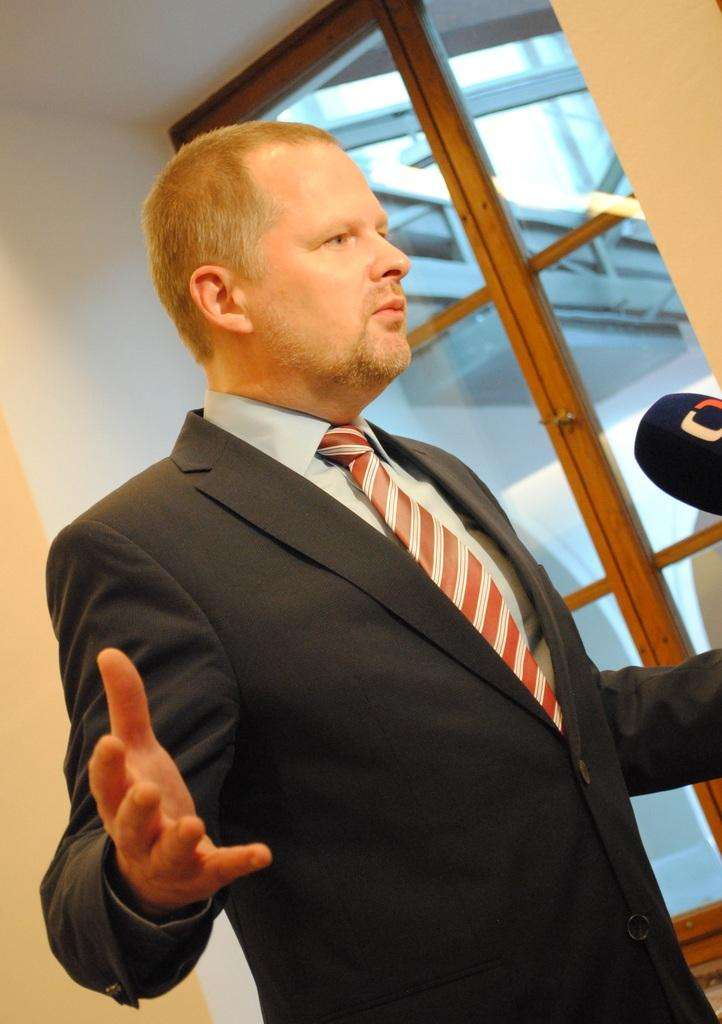Who is present in the image? There is a man in the image. What is the man wearing? The man is wearing a suit. What object is in front of the man? There is a microphone in front of the man. What can be seen on the right side of the image? There is a door on the right side of the image. What is on the left side of the image? There is a wall on the left side of the image. What shape is the needle in the image? There is no needle present in the image. How much profit does the man make in the image? The image does not provide information about the man's profit. 